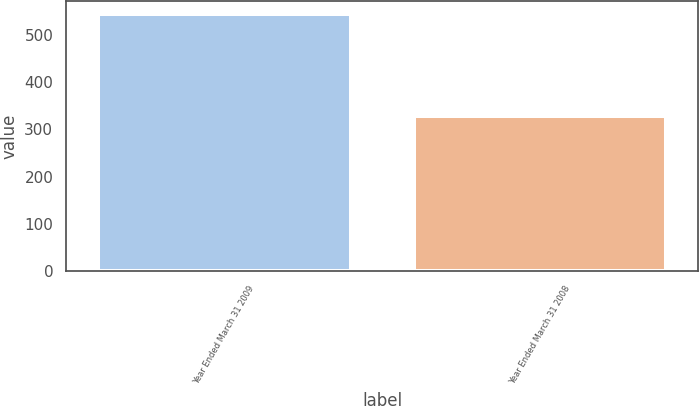Convert chart to OTSL. <chart><loc_0><loc_0><loc_500><loc_500><bar_chart><fcel>Year Ended March 31 2009<fcel>Year Ended March 31 2008<nl><fcel>543<fcel>328<nl></chart> 